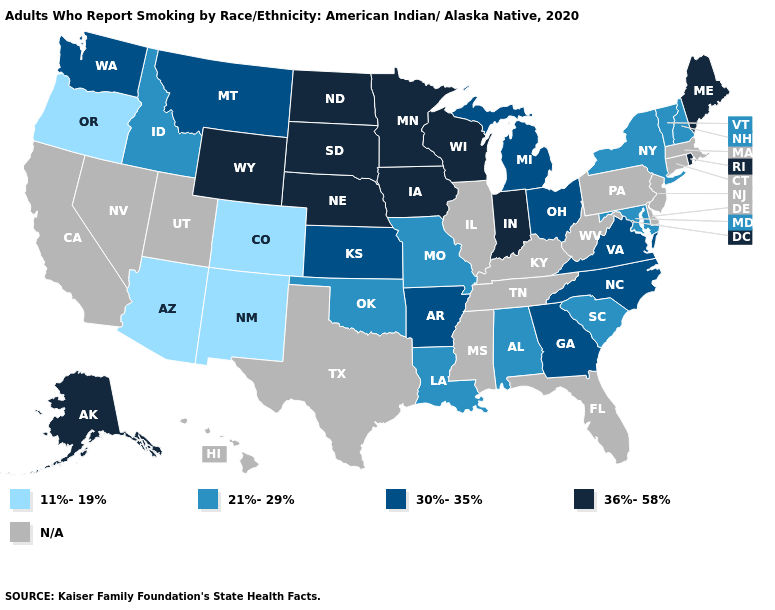Among the states that border Missouri , which have the lowest value?
Write a very short answer. Oklahoma. What is the value of Kentucky?
Quick response, please. N/A. Among the states that border Montana , does Idaho have the lowest value?
Give a very brief answer. Yes. What is the value of Rhode Island?
Give a very brief answer. 36%-58%. Name the states that have a value in the range 11%-19%?
Quick response, please. Arizona, Colorado, New Mexico, Oregon. Among the states that border Virginia , does North Carolina have the lowest value?
Short answer required. No. Is the legend a continuous bar?
Give a very brief answer. No. Does the map have missing data?
Quick response, please. Yes. Does Iowa have the lowest value in the MidWest?
Write a very short answer. No. What is the value of West Virginia?
Short answer required. N/A. Name the states that have a value in the range 11%-19%?
Give a very brief answer. Arizona, Colorado, New Mexico, Oregon. Name the states that have a value in the range N/A?
Give a very brief answer. California, Connecticut, Delaware, Florida, Hawaii, Illinois, Kentucky, Massachusetts, Mississippi, Nevada, New Jersey, Pennsylvania, Tennessee, Texas, Utah, West Virginia. What is the lowest value in states that border Texas?
Write a very short answer. 11%-19%. 